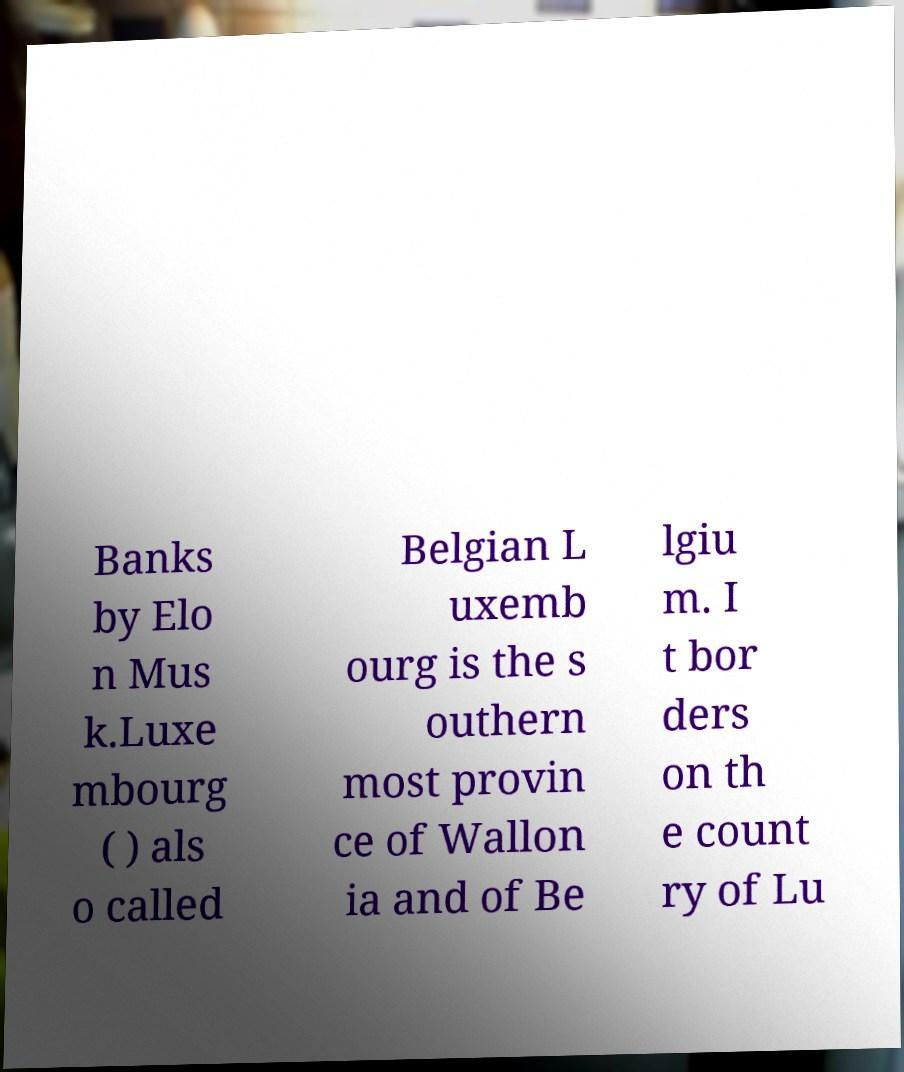There's text embedded in this image that I need extracted. Can you transcribe it verbatim? Banks by Elo n Mus k.Luxe mbourg ( ) als o called Belgian L uxemb ourg is the s outhern most provin ce of Wallon ia and of Be lgiu m. I t bor ders on th e count ry of Lu 